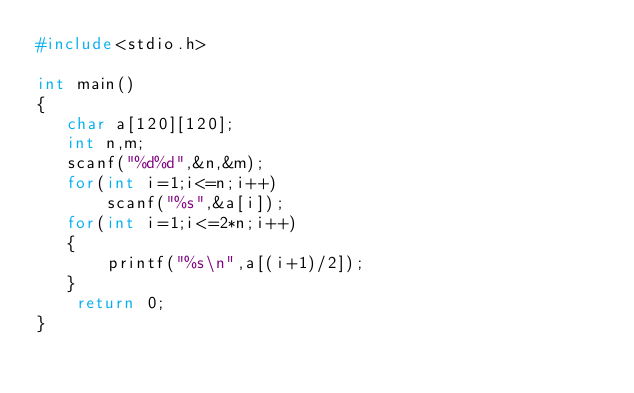Convert code to text. <code><loc_0><loc_0><loc_500><loc_500><_C++_>#include<stdio.h>

int main()
{
   char a[120][120];
   int n,m;
   scanf("%d%d",&n,&m);
   for(int i=1;i<=n;i++)
       scanf("%s",&a[i]);
   for(int i=1;i<=2*n;i++)
   {
       printf("%s\n",a[(i+1)/2]);
   }
    return 0;
}
</code> 